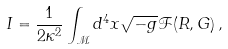Convert formula to latex. <formula><loc_0><loc_0><loc_500><loc_500>I = \frac { 1 } { 2 \kappa ^ { 2 } } \int _ { \mathcal { M } } d ^ { 4 } x \sqrt { - g } \mathcal { F } ( R , G ) \, ,</formula> 